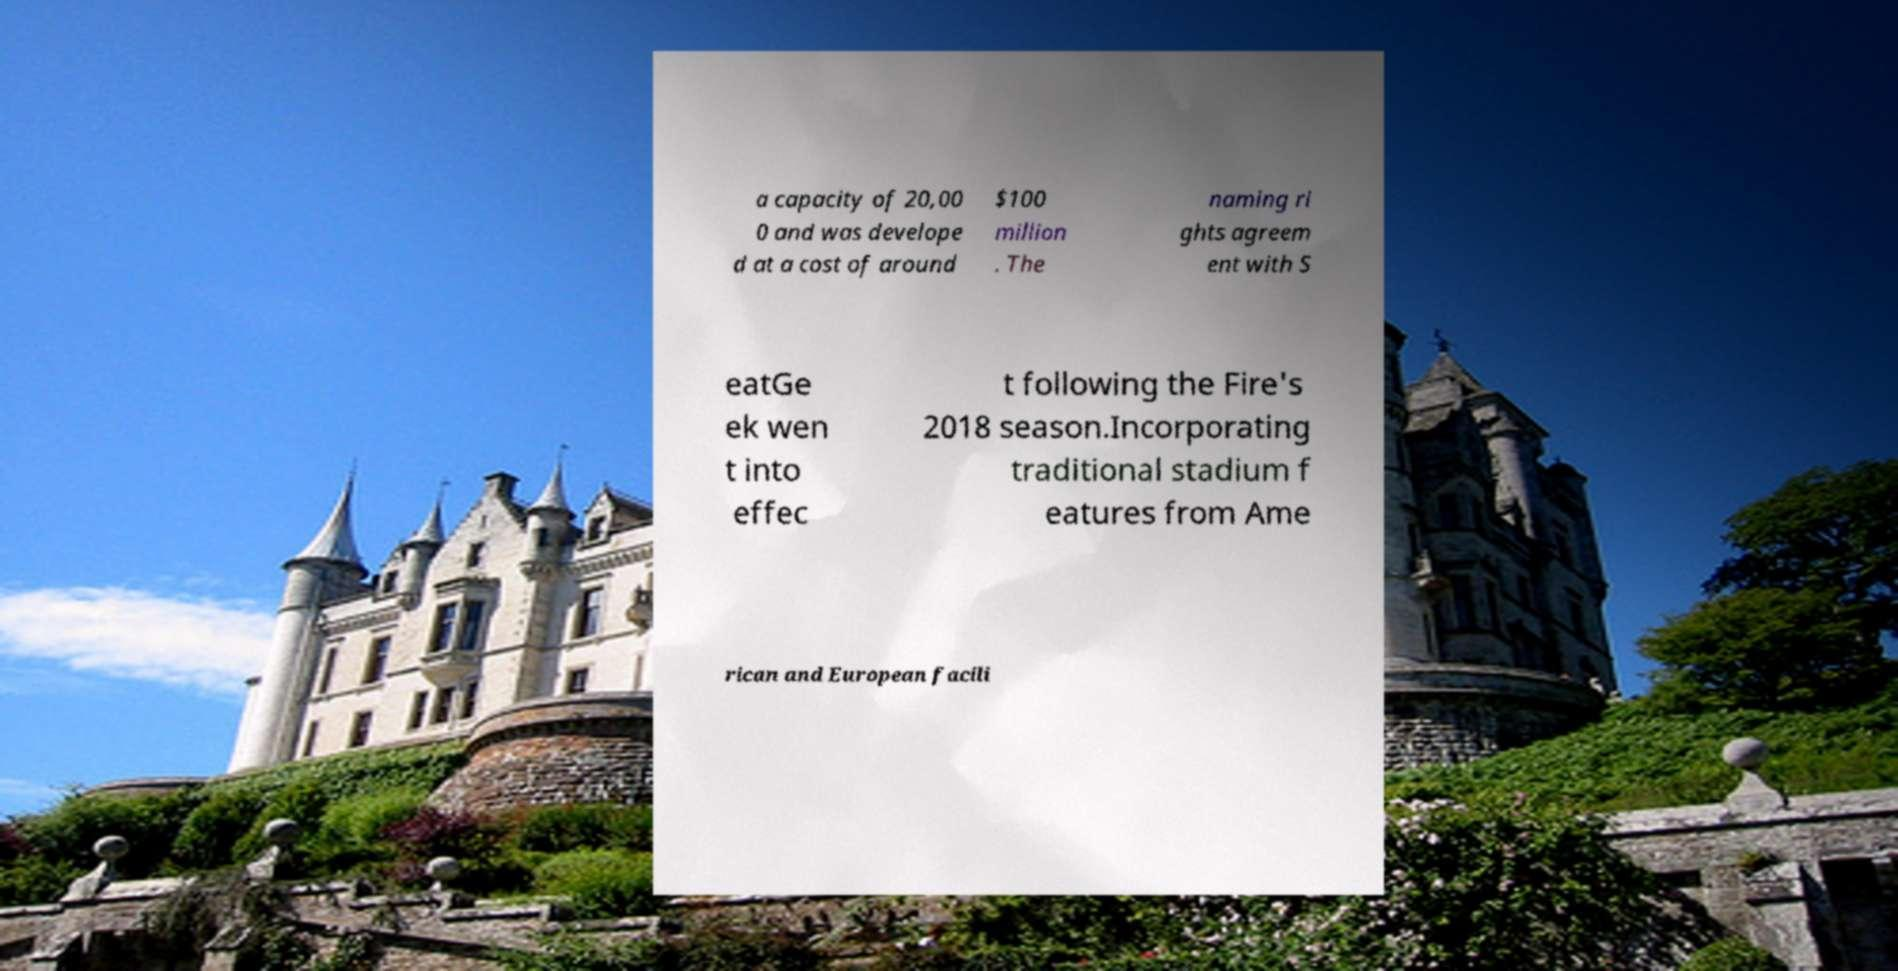What messages or text are displayed in this image? I need them in a readable, typed format. a capacity of 20,00 0 and was develope d at a cost of around $100 million . The naming ri ghts agreem ent with S eatGe ek wen t into effec t following the Fire's 2018 season.Incorporating traditional stadium f eatures from Ame rican and European facili 